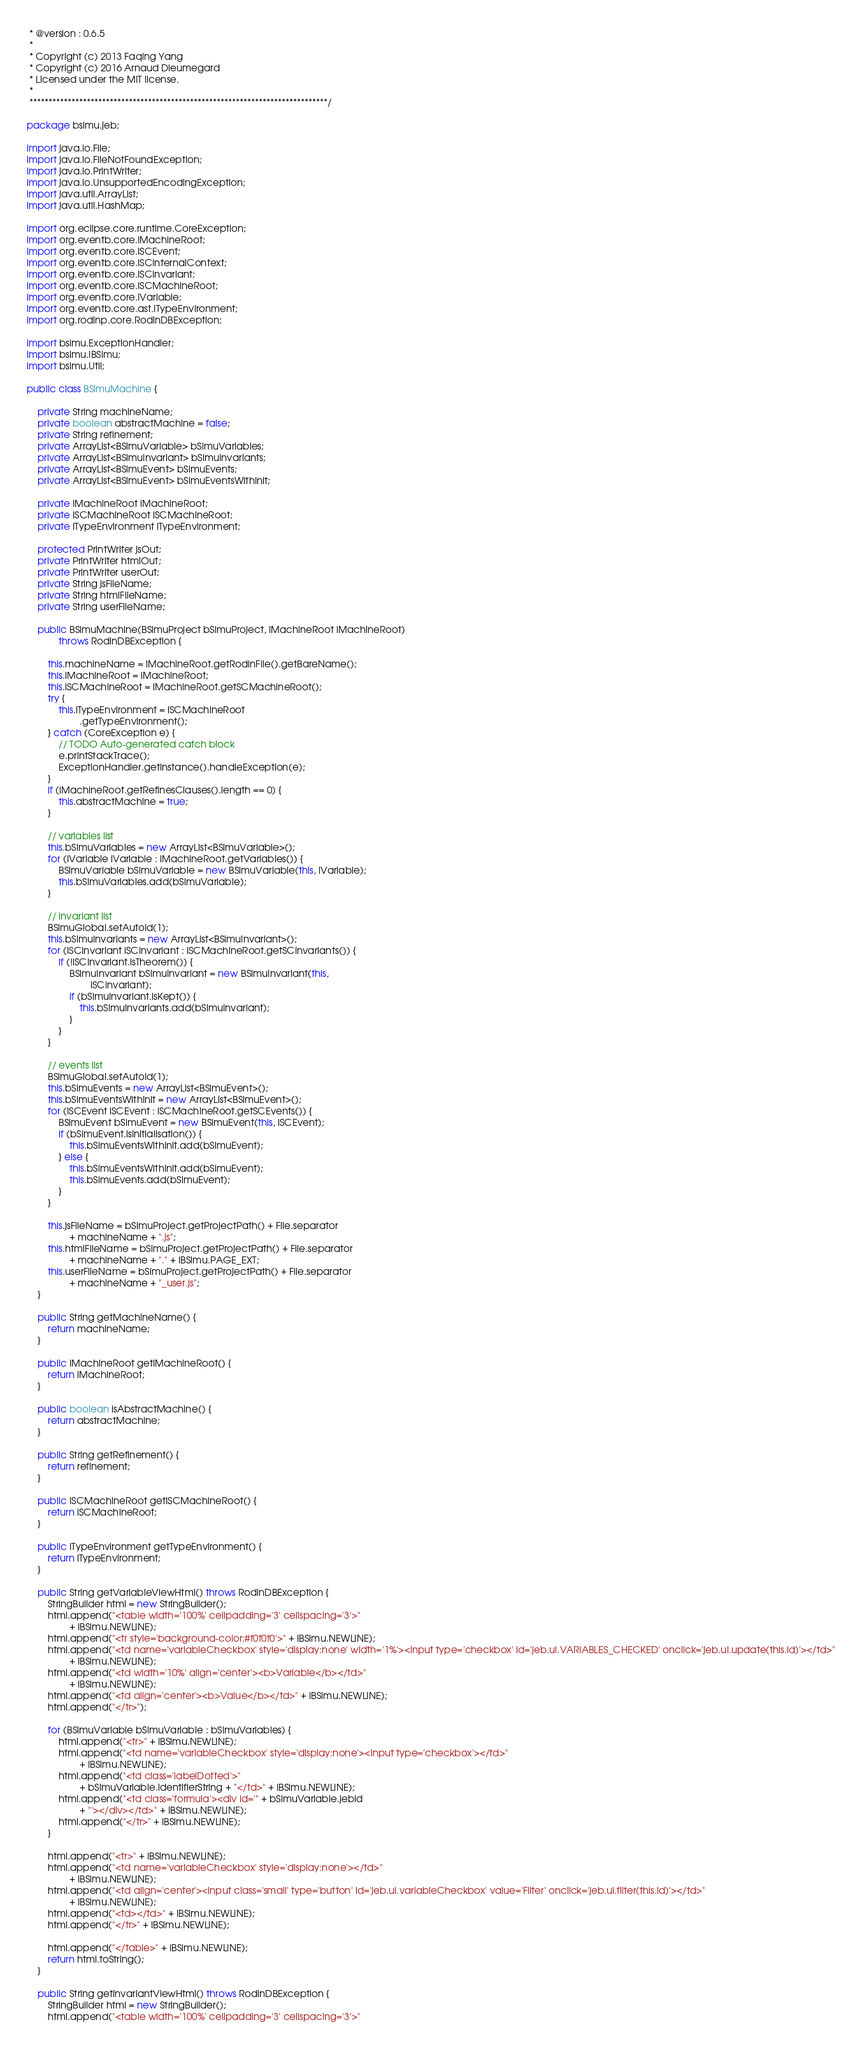<code> <loc_0><loc_0><loc_500><loc_500><_Java_> * @version : 0.6.5
 *
 * Copyright (c) 2013 Faqing Yang
 * Copyright (c) 2016 Arnaud Dieumegard
 * Licensed under the MIT license.
 * 
 ******************************************************************************/

package bsimu.jeb;

import java.io.File;
import java.io.FileNotFoundException;
import java.io.PrintWriter;
import java.io.UnsupportedEncodingException;
import java.util.ArrayList;
import java.util.HashMap;

import org.eclipse.core.runtime.CoreException;
import org.eventb.core.IMachineRoot;
import org.eventb.core.ISCEvent;
import org.eventb.core.ISCInternalContext;
import org.eventb.core.ISCInvariant;
import org.eventb.core.ISCMachineRoot;
import org.eventb.core.IVariable;
import org.eventb.core.ast.ITypeEnvironment;
import org.rodinp.core.RodinDBException;

import bsimu.ExceptionHandler;
import bsimu.IBSimu;
import bsimu.Util;

public class BSimuMachine {

	private String machineName;
	private boolean abstractMachine = false;
	private String refinement;
	private ArrayList<BSimuVariable> bSimuVariables;
	private ArrayList<BSimuInvariant> bSimuInvariants;
	private ArrayList<BSimuEvent> bSimuEvents;
	private ArrayList<BSimuEvent> bSimuEventsWithInit;

	private IMachineRoot iMachineRoot;
	private ISCMachineRoot iSCMachineRoot;
	private ITypeEnvironment iTypeEnvironment;

	protected PrintWriter jsOut;
	private PrintWriter htmlOut;
	private PrintWriter userOut;
	private String jsFileName;
	private String htmlFileName;
	private String userFileName;

	public BSimuMachine(BSimuProject bSimuProject, IMachineRoot iMachineRoot)
			throws RodinDBException {

		this.machineName = iMachineRoot.getRodinFile().getBareName();
		this.iMachineRoot = iMachineRoot;
		this.iSCMachineRoot = iMachineRoot.getSCMachineRoot();
		try {
			this.iTypeEnvironment = iSCMachineRoot
					.getTypeEnvironment();
		} catch (CoreException e) {
			// TODO Auto-generated catch block
			e.printStackTrace();
			ExceptionHandler.getInstance().handleException(e);
		}
		if (iMachineRoot.getRefinesClauses().length == 0) {
			this.abstractMachine = true;
		}

		// variables list
		this.bSimuVariables = new ArrayList<BSimuVariable>();
		for (IVariable iVariable : iMachineRoot.getVariables()) {
			BSimuVariable bSimuVariable = new BSimuVariable(this, iVariable);
			this.bSimuVariables.add(bSimuVariable);
		}

		// invariant list
		BSimuGlobal.setAutoId(1);
		this.bSimuInvariants = new ArrayList<BSimuInvariant>();
		for (ISCInvariant iSCInvariant : iSCMachineRoot.getSCInvariants()) {
			if (!iSCInvariant.isTheorem()) {
				BSimuInvariant bSimuInvariant = new BSimuInvariant(this,
						iSCInvariant);
				if (bSimuInvariant.isKept()) {
					this.bSimuInvariants.add(bSimuInvariant);
				}
			}
		}

		// events list
		BSimuGlobal.setAutoId(1);
		this.bSimuEvents = new ArrayList<BSimuEvent>();
		this.bSimuEventsWithInit = new ArrayList<BSimuEvent>();
		for (ISCEvent iSCEvent : iSCMachineRoot.getSCEvents()) {
			BSimuEvent bSimuEvent = new BSimuEvent(this, iSCEvent);
			if (bSimuEvent.isInitialisation()) {
				this.bSimuEventsWithInit.add(bSimuEvent);
			} else {
				this.bSimuEventsWithInit.add(bSimuEvent);
				this.bSimuEvents.add(bSimuEvent);
			}
		}

		this.jsFileName = bSimuProject.getProjectPath() + File.separator
				+ machineName + ".js";
		this.htmlFileName = bSimuProject.getProjectPath() + File.separator
				+ machineName + "." + IBSimu.PAGE_EXT;
		this.userFileName = bSimuProject.getProjectPath() + File.separator
				+ machineName + "_user.js";
	}

	public String getMachineName() {
		return machineName;
	}

	public IMachineRoot getIMachineRoot() {
		return iMachineRoot;
	}

	public boolean isAbstractMachine() {
		return abstractMachine;
	}

	public String getRefinement() {
		return refinement;
	}

	public ISCMachineRoot getISCMachineRoot() {
		return iSCMachineRoot;
	}

	public ITypeEnvironment getTypeEnvironment() {
		return iTypeEnvironment;
	}

	public String getVariableViewHtml() throws RodinDBException {
		StringBuilder html = new StringBuilder();
		html.append("<table width='100%' cellpadding='3' cellspacing='3'>"
				+ IBSimu.NEWLINE);
		html.append("<tr style='background-color:#f0f0f0'>" + IBSimu.NEWLINE);
		html.append("<td name='variableCheckbox' style='display:none' width='1%'><input type='checkbox' id='jeb.ui.VARIABLES_CHECKED' onclick='jeb.ui.update(this.id)'></td>"
				+ IBSimu.NEWLINE);
		html.append("<td width='10%' align='center'><b>Variable</b></td>"
				+ IBSimu.NEWLINE);
		html.append("<td align='center'><b>Value</b></td>" + IBSimu.NEWLINE);
		html.append("</tr>");

		for (BSimuVariable bSimuVariable : bSimuVariables) {
			html.append("<tr>" + IBSimu.NEWLINE);
			html.append("<td name='variableCheckbox' style='display:none'><input type='checkbox'></td>"
					+ IBSimu.NEWLINE);
			html.append("<td class='labelDotted'>"
					+ bSimuVariable.identifierString + "</td>" + IBSimu.NEWLINE);
			html.append("<td class='formula'><div id='" + bSimuVariable.jebId
					+ "'></div></td>" + IBSimu.NEWLINE);
			html.append("</tr>" + IBSimu.NEWLINE);
		}

		html.append("<tr>" + IBSimu.NEWLINE);
		html.append("<td name='variableCheckbox' style='display:none'></td>"
				+ IBSimu.NEWLINE);
		html.append("<td align='center'><input class='small' type='button' id='jeb.ui.variableCheckbox' value='Filter' onclick='jeb.ui.filter(this.id)'></td>"
				+ IBSimu.NEWLINE);
		html.append("<td></td>" + IBSimu.NEWLINE);
		html.append("</tr>" + IBSimu.NEWLINE);

		html.append("</table>" + IBSimu.NEWLINE);
		return html.toString();
	}

	public String getInvariantViewHtml() throws RodinDBException {
		StringBuilder html = new StringBuilder();
		html.append("<table width='100%' cellpadding='3' cellspacing='3'>"</code> 